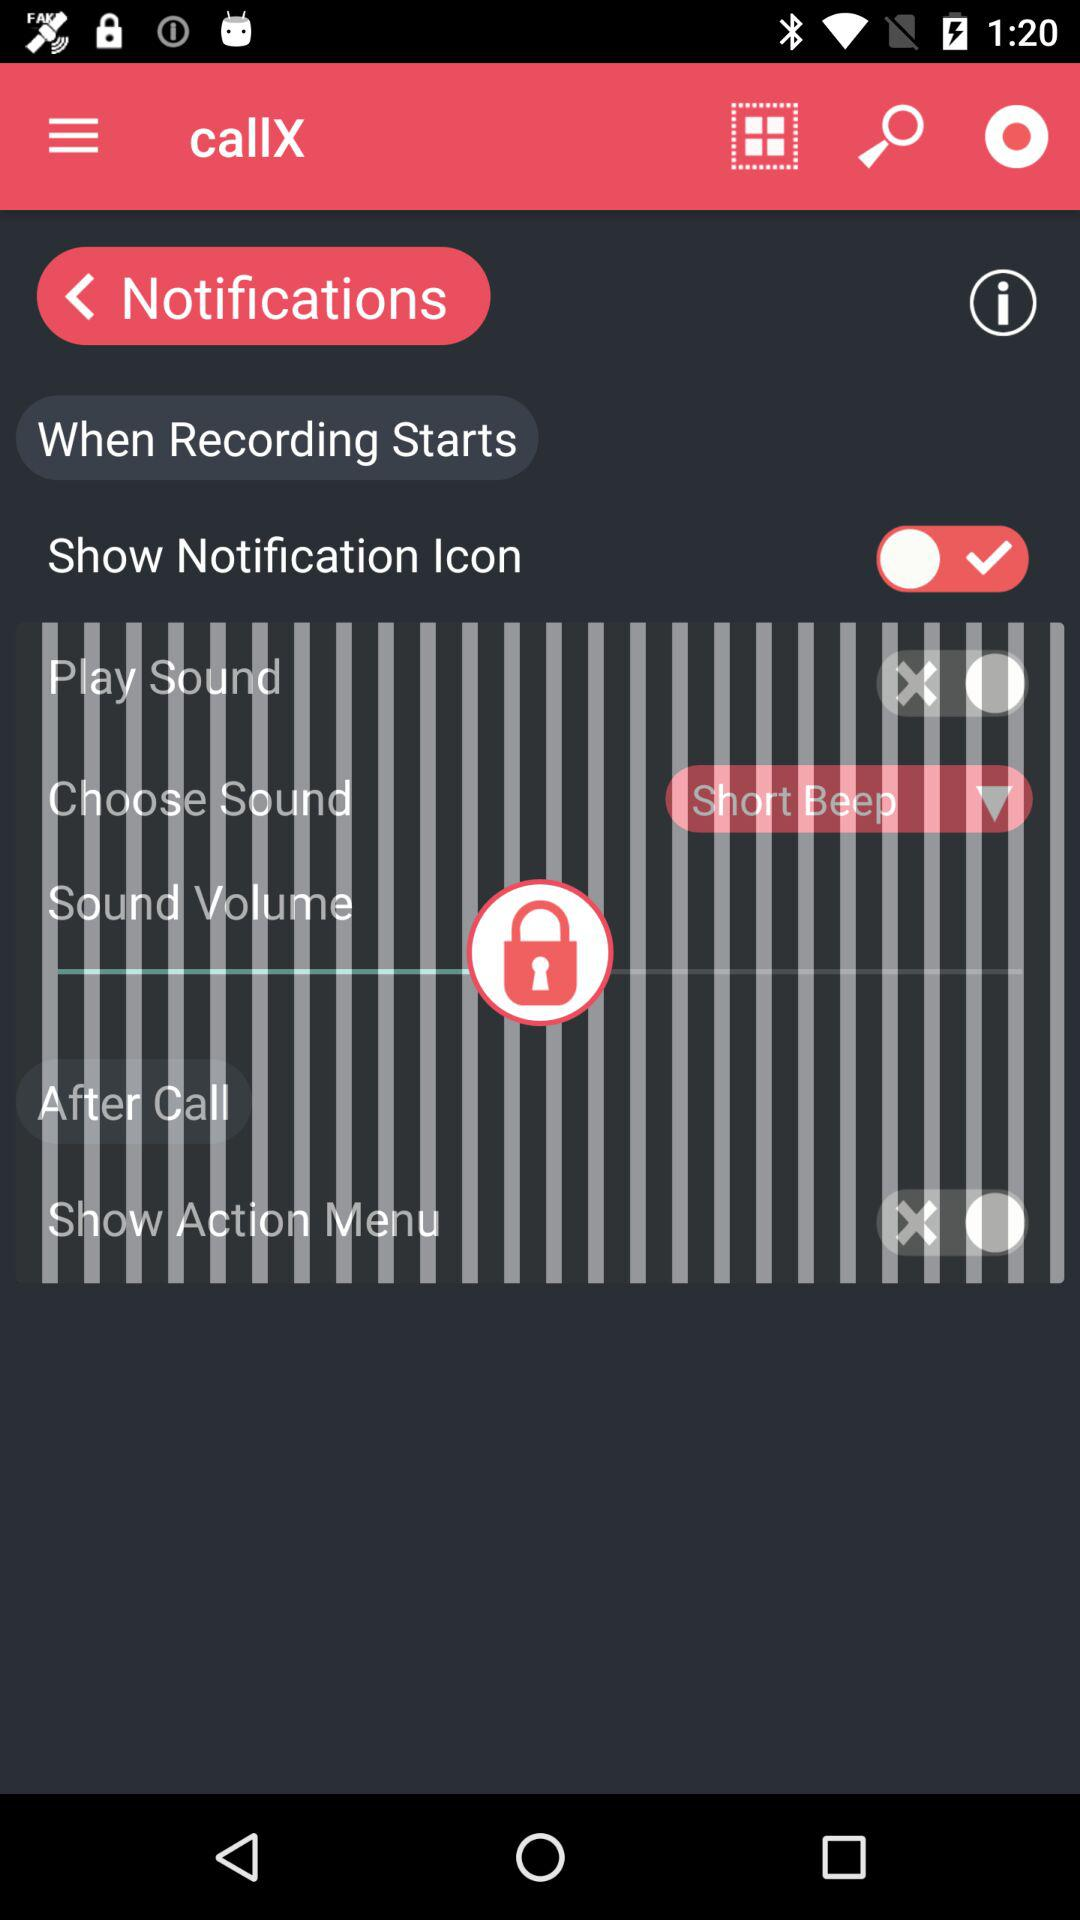What is the status of the show notification icon? The status is "on". 